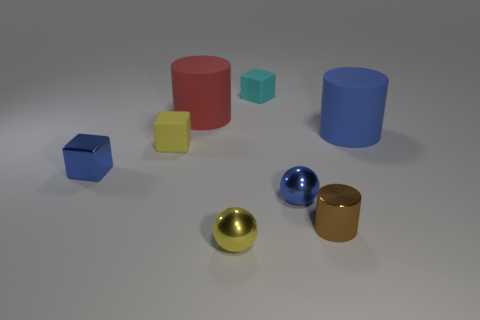Subtract all red spheres. Subtract all gray blocks. How many spheres are left? 2 Add 1 large brown cylinders. How many objects exist? 9 Subtract all balls. How many objects are left? 6 Subtract 1 blue cubes. How many objects are left? 7 Subtract all big rubber things. Subtract all red matte things. How many objects are left? 5 Add 6 tiny blue spheres. How many tiny blue spheres are left? 7 Add 1 tiny blue rubber balls. How many tiny blue rubber balls exist? 1 